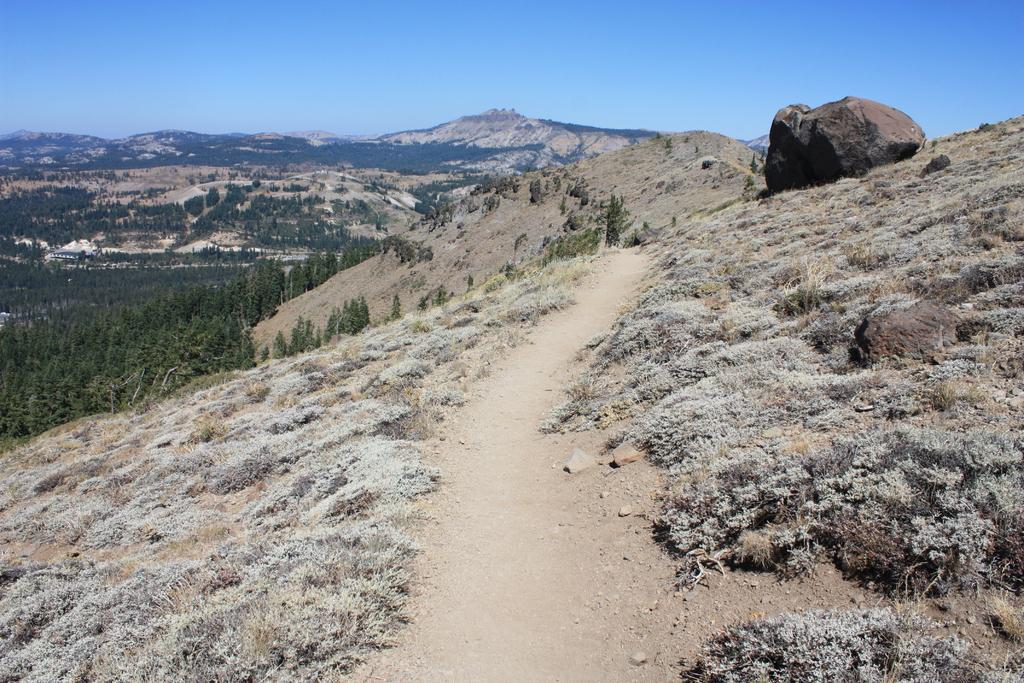Can you describe this image briefly? In this image, we can see the walkway, plants and rocks. Background we can see trees, hills and sky. 